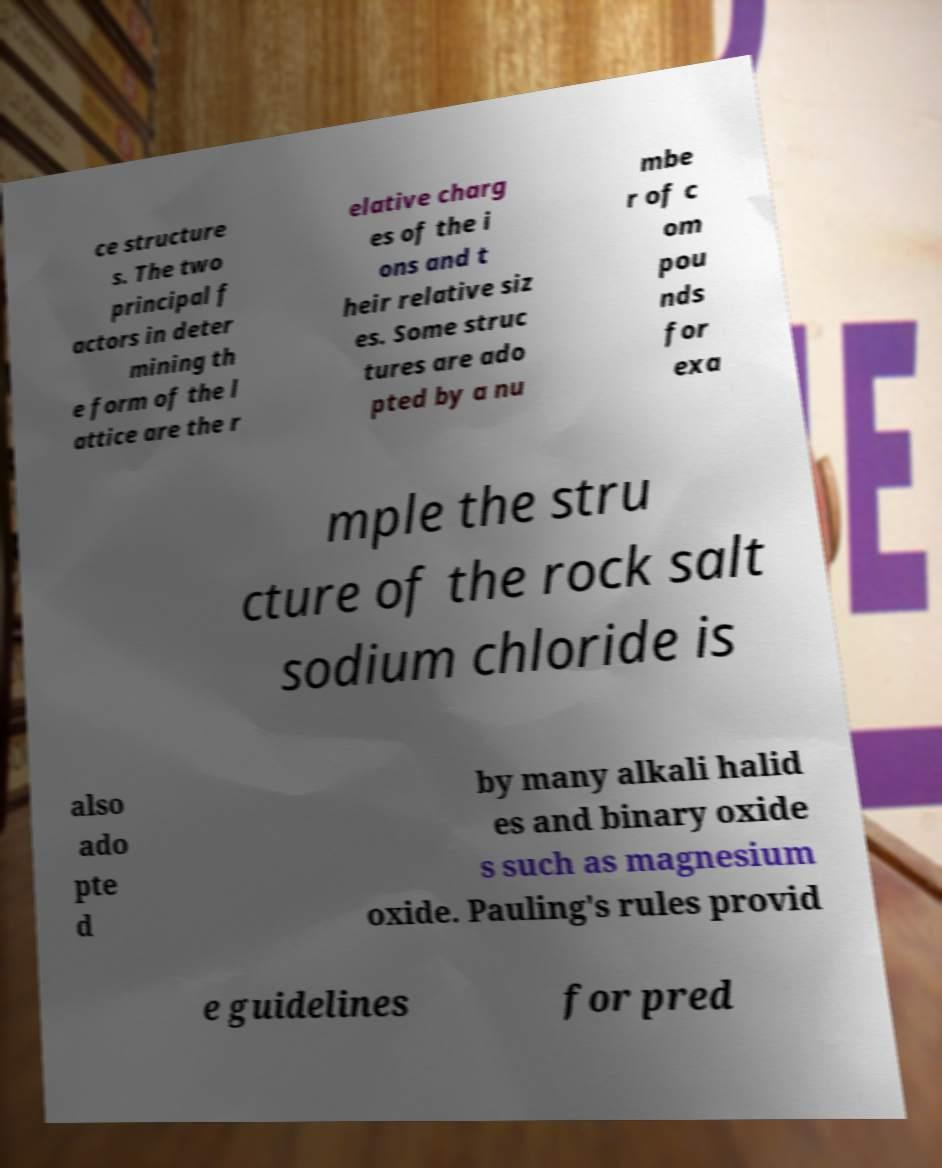There's text embedded in this image that I need extracted. Can you transcribe it verbatim? ce structure s. The two principal f actors in deter mining th e form of the l attice are the r elative charg es of the i ons and t heir relative siz es. Some struc tures are ado pted by a nu mbe r of c om pou nds for exa mple the stru cture of the rock salt sodium chloride is also ado pte d by many alkali halid es and binary oxide s such as magnesium oxide. Pauling's rules provid e guidelines for pred 